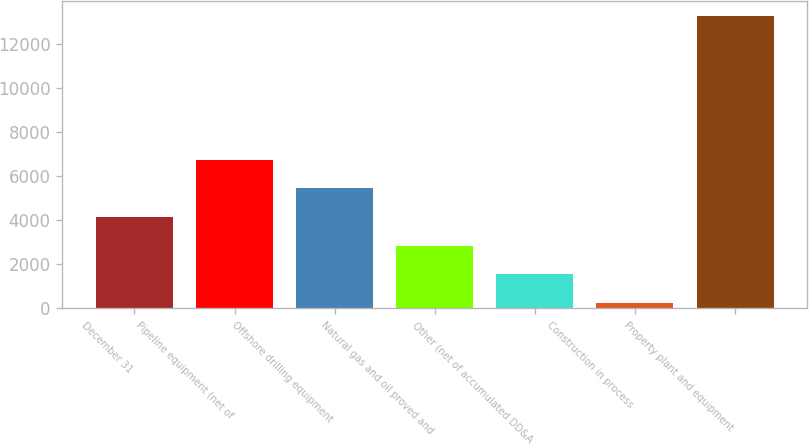Convert chart. <chart><loc_0><loc_0><loc_500><loc_500><bar_chart><fcel>December 31<fcel>Pipeline equipment (net of<fcel>Offshore drilling equipment<fcel>Natural gas and oil proved and<fcel>Other (net of accumulated DD&A<fcel>Construction in process<fcel>Property plant and equipment<nl><fcel>4146<fcel>6754<fcel>5450<fcel>2842<fcel>1538<fcel>234<fcel>13274<nl></chart> 